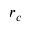Convert formula to latex. <formula><loc_0><loc_0><loc_500><loc_500>r _ { c }</formula> 